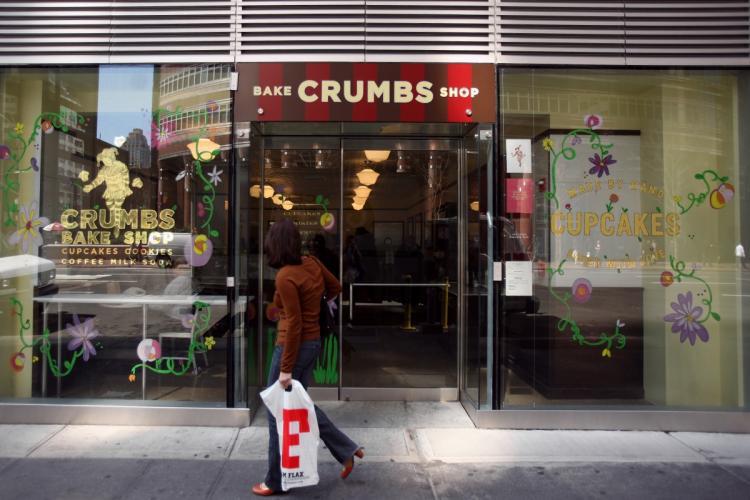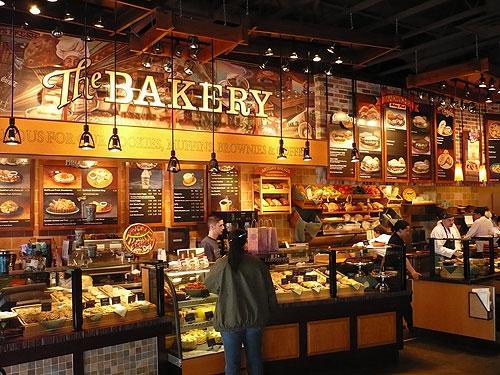The first image is the image on the left, the second image is the image on the right. Given the left and right images, does the statement "An image shows at least one person on the sidewalk in front of the shop in the daytime." hold true? Answer yes or no. Yes. 